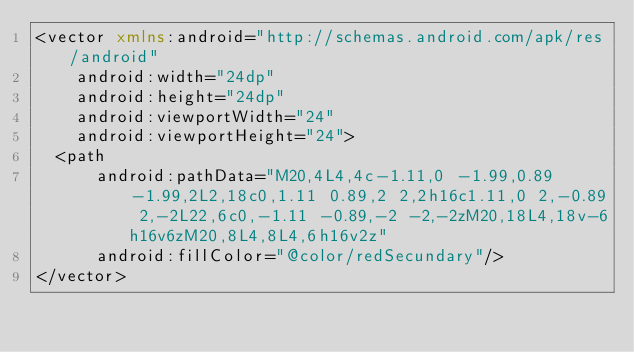<code> <loc_0><loc_0><loc_500><loc_500><_XML_><vector xmlns:android="http://schemas.android.com/apk/res/android"
    android:width="24dp"
    android:height="24dp"
    android:viewportWidth="24"
    android:viewportHeight="24">
  <path
      android:pathData="M20,4L4,4c-1.11,0 -1.99,0.89 -1.99,2L2,18c0,1.11 0.89,2 2,2h16c1.11,0 2,-0.89 2,-2L22,6c0,-1.11 -0.89,-2 -2,-2zM20,18L4,18v-6h16v6zM20,8L4,8L4,6h16v2z"
      android:fillColor="@color/redSecundary"/>
</vector>
</code> 